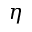Convert formula to latex. <formula><loc_0><loc_0><loc_500><loc_500>\eta</formula> 